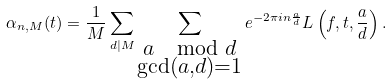Convert formula to latex. <formula><loc_0><loc_0><loc_500><loc_500>\alpha _ { n , M } ( t ) = \frac { 1 } { M } \sum _ { d | M } \sum _ { \substack { a \mod d \\ \gcd ( a , d ) = 1 } } e ^ { - 2 \pi i n \frac { a } { d } } L \left ( f , t , \frac { a } { d } \right ) .</formula> 